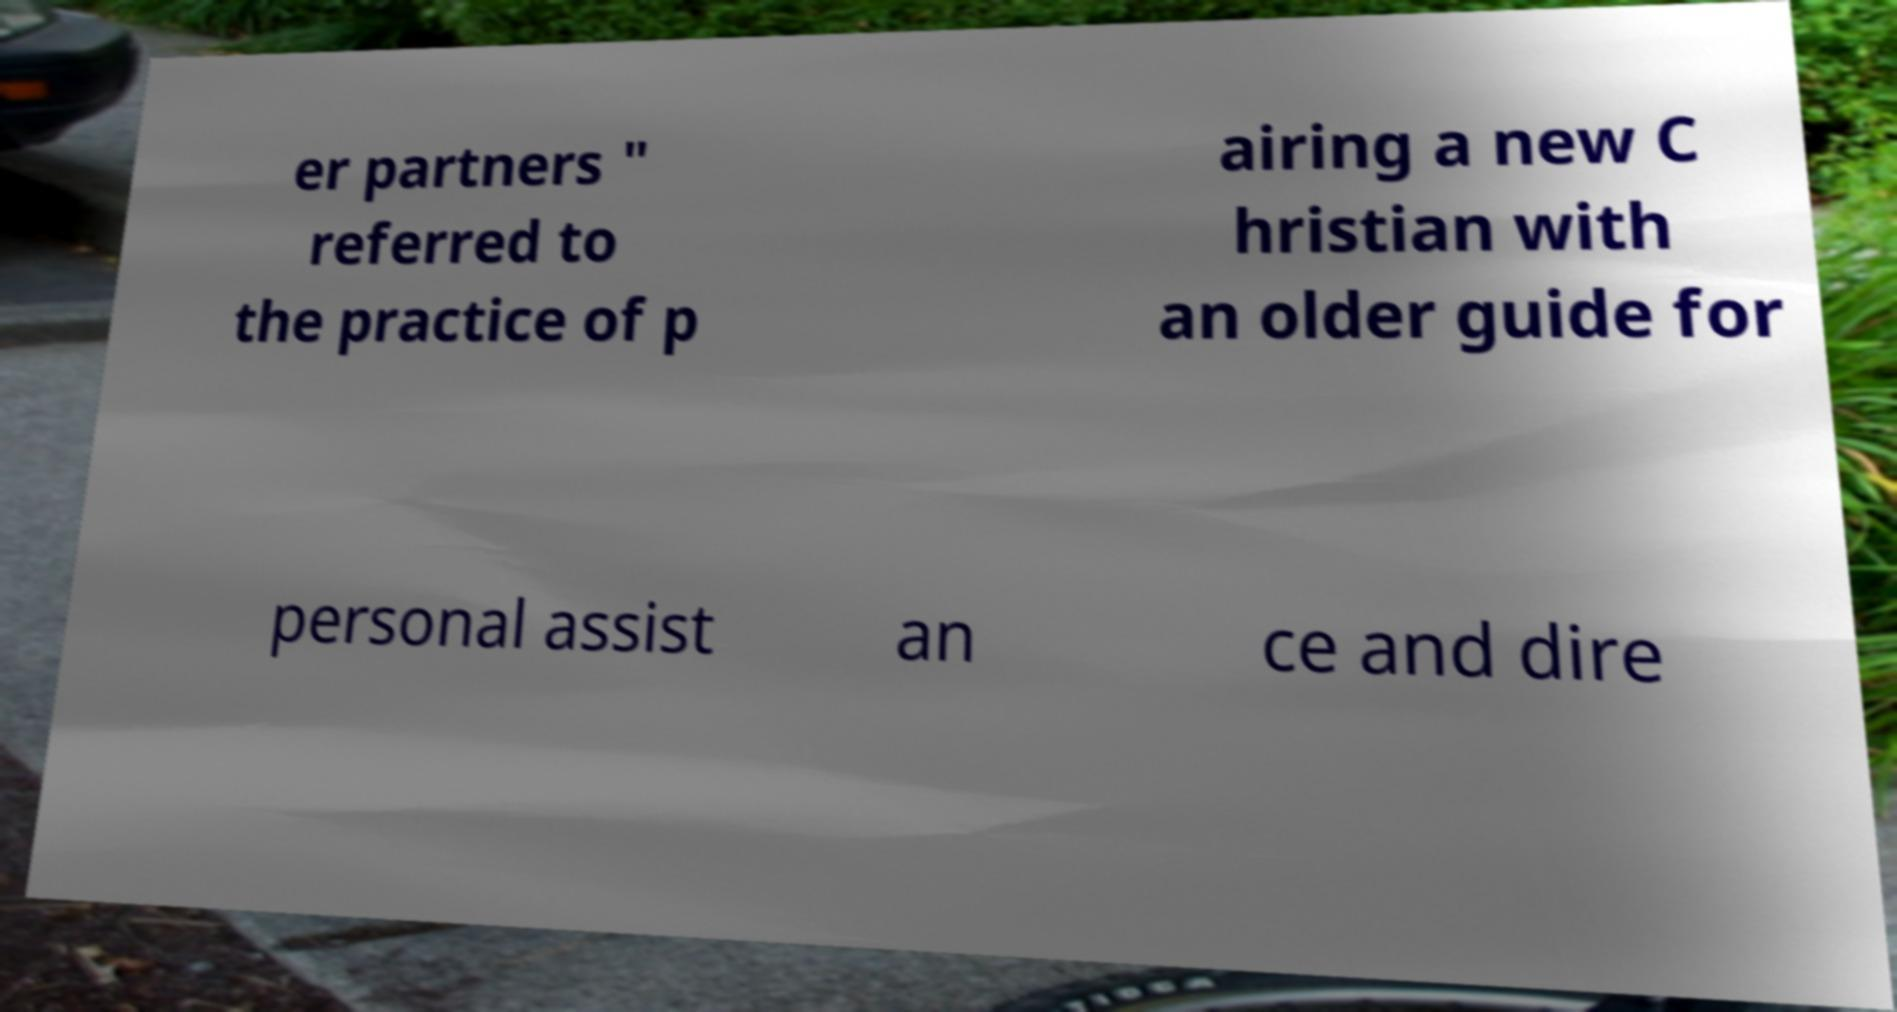Can you read and provide the text displayed in the image?This photo seems to have some interesting text. Can you extract and type it out for me? er partners " referred to the practice of p airing a new C hristian with an older guide for personal assist an ce and dire 